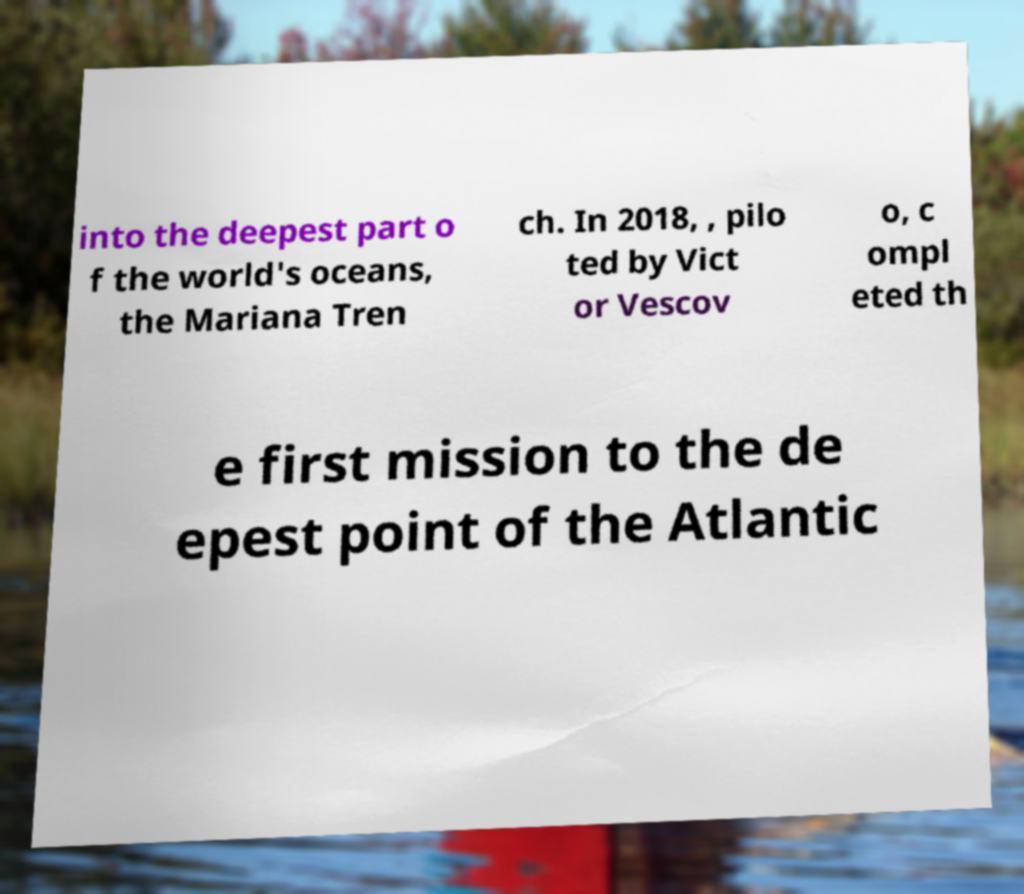For documentation purposes, I need the text within this image transcribed. Could you provide that? into the deepest part o f the world's oceans, the Mariana Tren ch. In 2018, , pilo ted by Vict or Vescov o, c ompl eted th e first mission to the de epest point of the Atlantic 